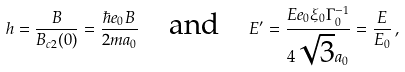Convert formula to latex. <formula><loc_0><loc_0><loc_500><loc_500>h = \frac { B } { B _ { c 2 } ( 0 ) } = \frac { \hbar { e } _ { 0 } B } { 2 m a _ { 0 } } \quad \text {and} \quad E ^ { \prime } = \frac { E e _ { 0 } \xi _ { 0 } \Gamma _ { 0 } ^ { - 1 } } { 4 \sqrt { 3 } a _ { 0 } } = \frac { E } { E _ { 0 } } \, ,</formula> 